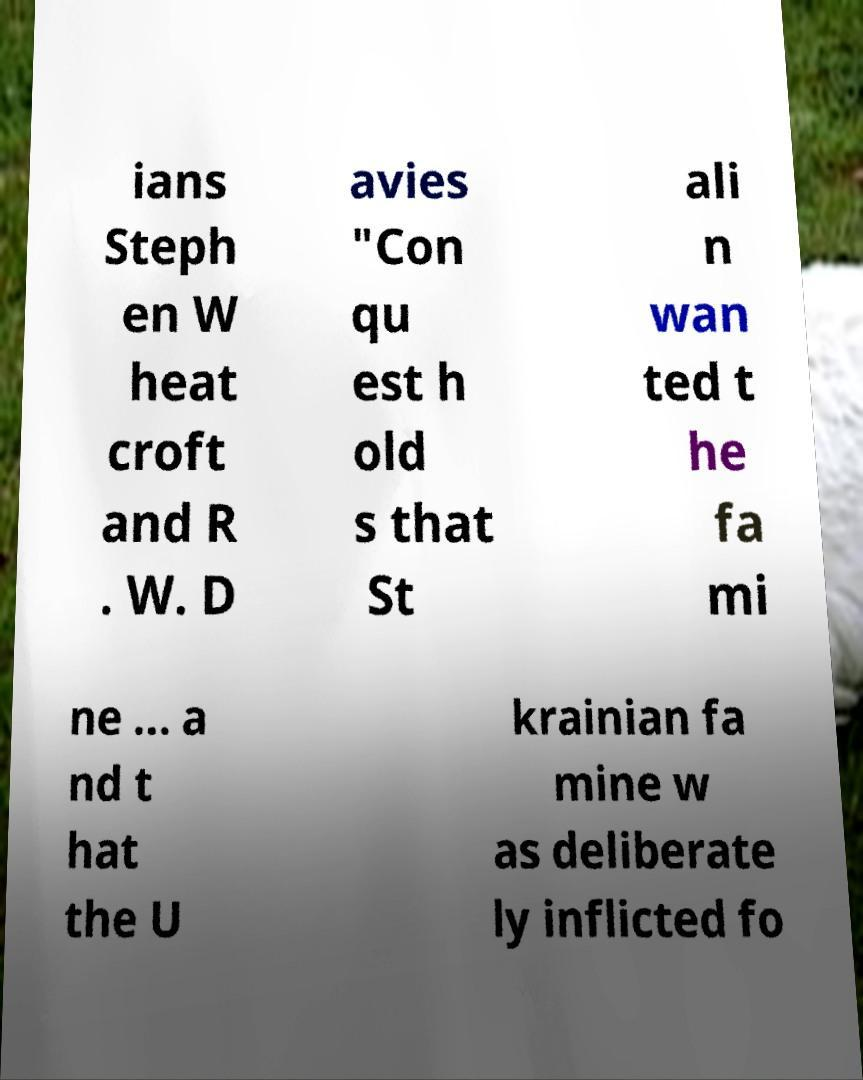Please read and relay the text visible in this image. What does it say? ians Steph en W heat croft and R . W. D avies "Con qu est h old s that St ali n wan ted t he fa mi ne ... a nd t hat the U krainian fa mine w as deliberate ly inflicted fo 